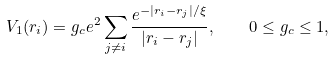<formula> <loc_0><loc_0><loc_500><loc_500>V _ { 1 } ( { r } _ { i } ) = g _ { c } e ^ { 2 } \sum _ { j \ne i } \frac { e ^ { - | { r } _ { i } - { r } _ { j } | / \xi } } { | { r } _ { i } - { r } _ { j } | } , \quad 0 \leq g _ { c } \leq 1 ,</formula> 